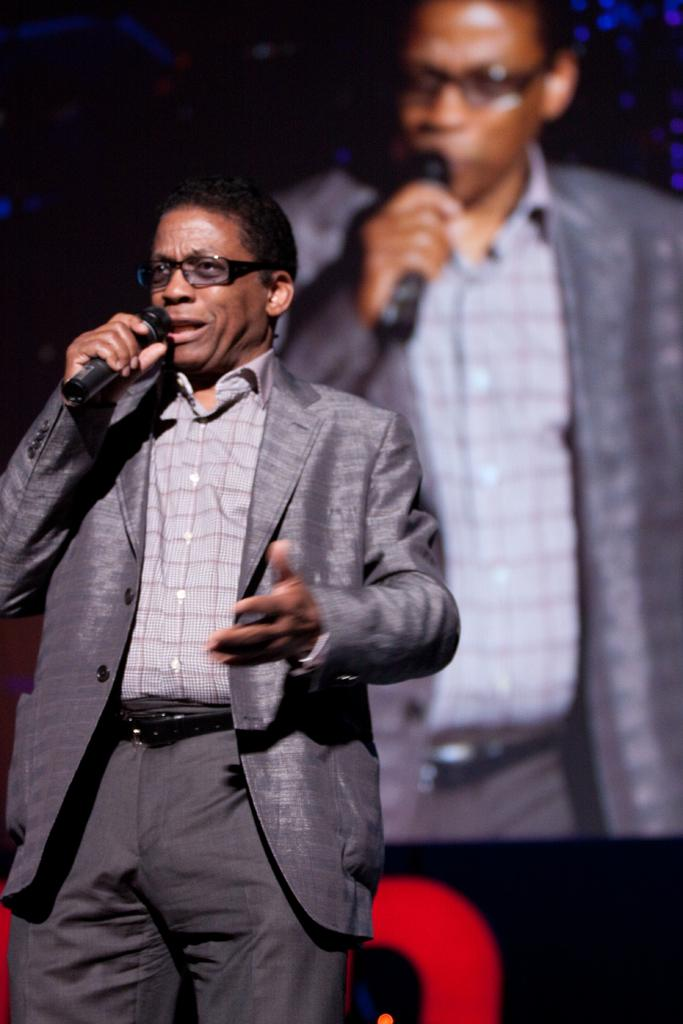Who is the main subject in the image? There is a man in the image. What is the man wearing? The man is wearing a grey suit. What is the man doing in the image? The man is talking on a mic. How many servants are visible in the image? There are no servants present in the image. What type of friction can be seen between the man and the mic in the image? There is no friction visible between the man and the mic in the image. 